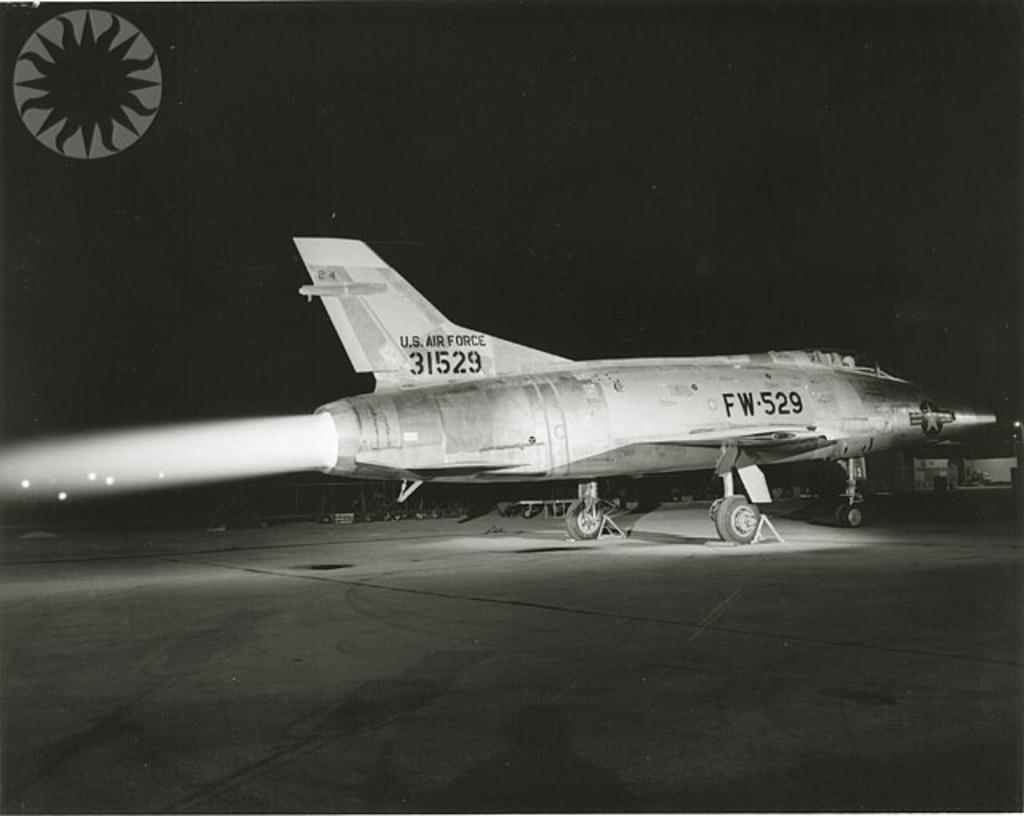<image>
Relay a brief, clear account of the picture shown. A U.S. Air Force, air plane is parked at night, with flames exerting from the back. 